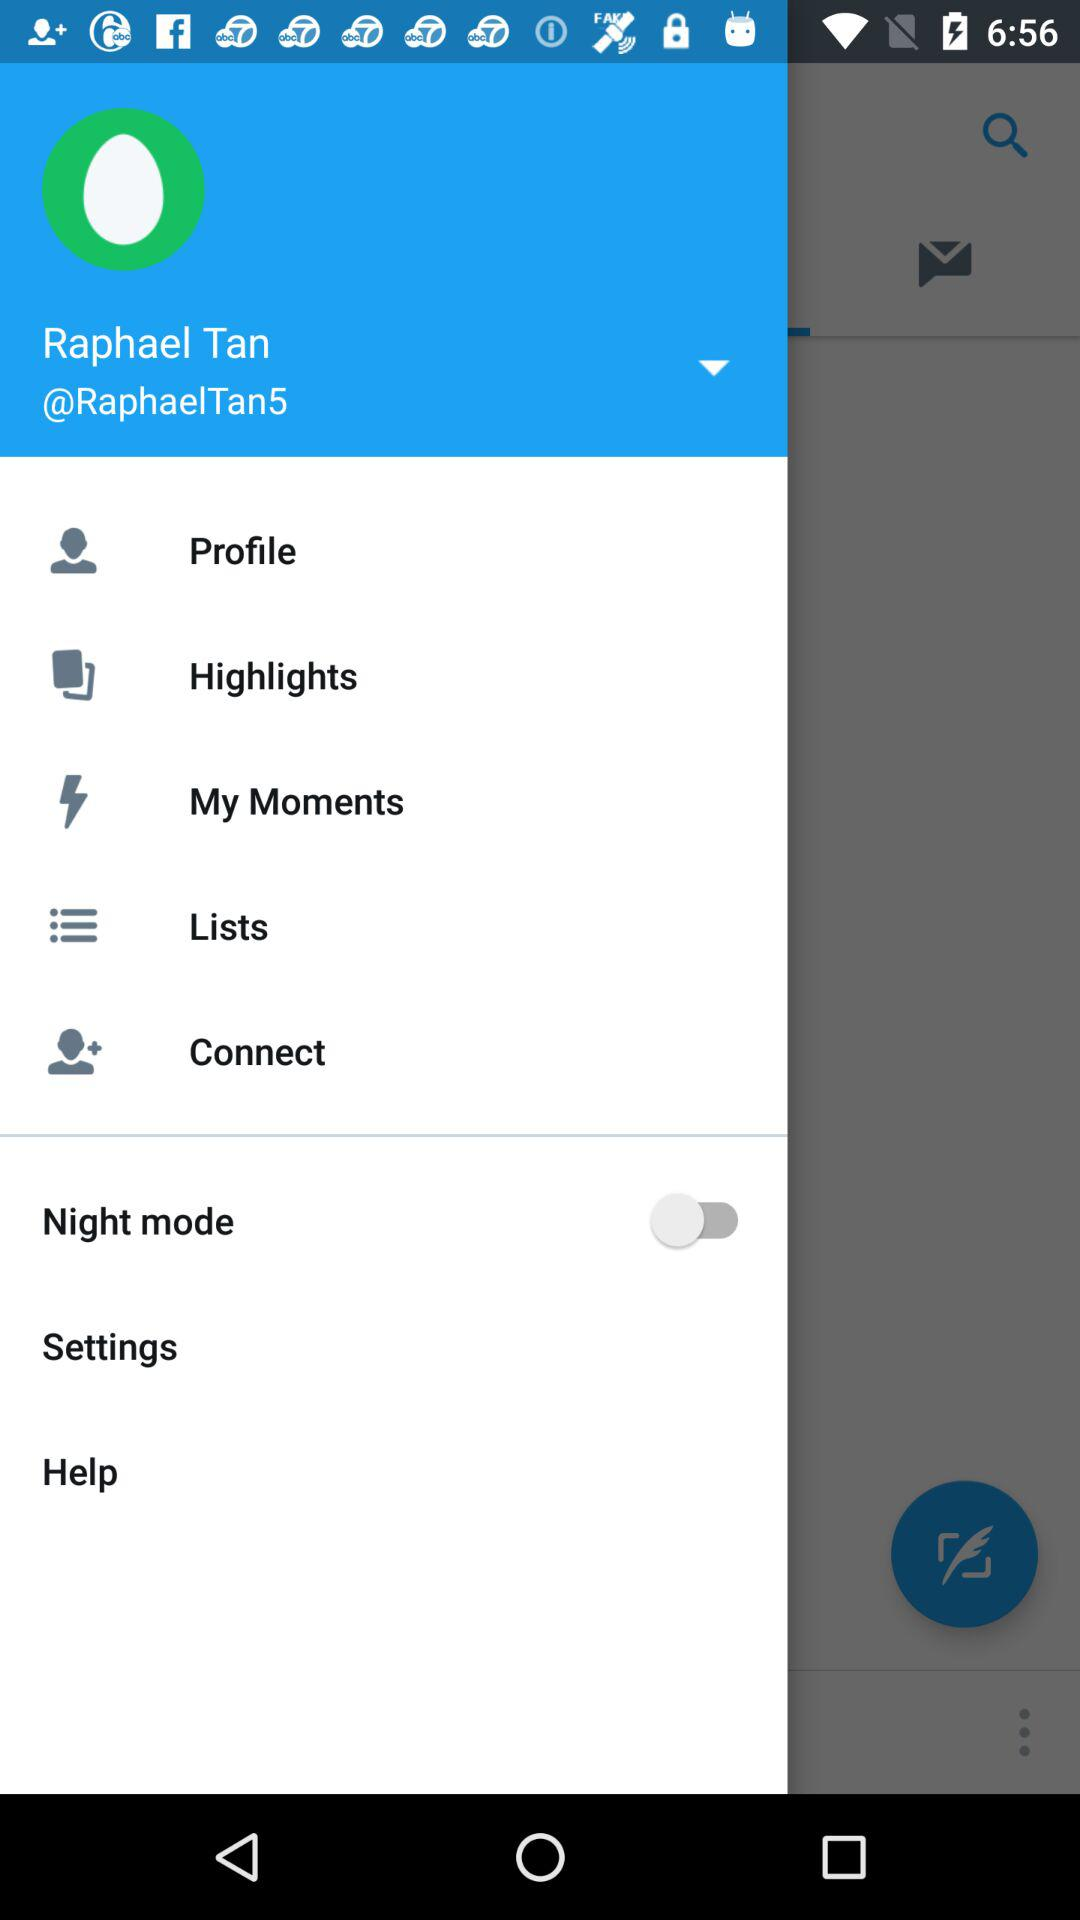What is the profile name? The profile name is Raphael Tan. 